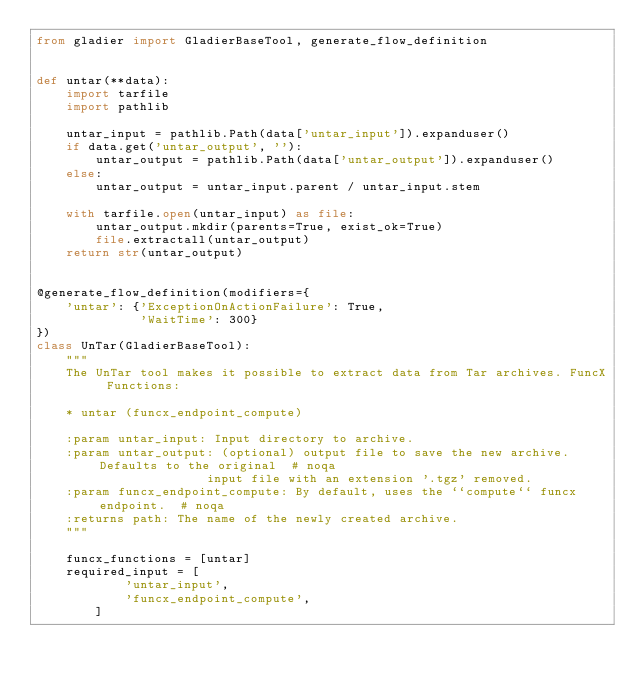<code> <loc_0><loc_0><loc_500><loc_500><_Python_>from gladier import GladierBaseTool, generate_flow_definition


def untar(**data):
    import tarfile
    import pathlib

    untar_input = pathlib.Path(data['untar_input']).expanduser()
    if data.get('untar_output', ''):
        untar_output = pathlib.Path(data['untar_output']).expanduser()
    else:
        untar_output = untar_input.parent / untar_input.stem

    with tarfile.open(untar_input) as file:
        untar_output.mkdir(parents=True, exist_ok=True)
        file.extractall(untar_output)
    return str(untar_output)


@generate_flow_definition(modifiers={
    'untar': {'ExceptionOnActionFailure': True,
              'WaitTime': 300}
})
class UnTar(GladierBaseTool):
    """
    The UnTar tool makes it possible to extract data from Tar archives. FuncX Functions:

    * untar (funcx_endpoint_compute)

    :param untar_input: Input directory to archive.
    :param untar_output: (optional) output file to save the new archive. Defaults to the original  # noqa
                       input file with an extension '.tgz' removed.
    :param funcx_endpoint_compute: By default, uses the ``compute`` funcx endpoint.  # noqa
    :returns path: The name of the newly created archive.
    """

    funcx_functions = [untar]
    required_input = [
            'untar_input',
            'funcx_endpoint_compute',
        ]
</code> 